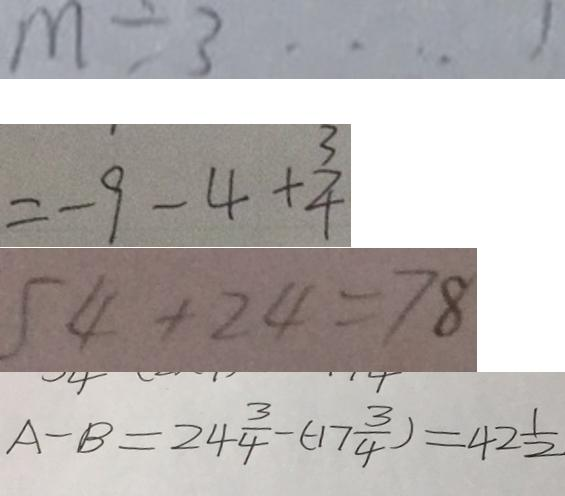Convert formula to latex. <formula><loc_0><loc_0><loc_500><loc_500>m \div 3 \cdots 1 
 = - 9 - 4 + \frac { 3 } { 4 } 
 5 4 + 2 4 = 7 8 
 A - B = 2 4 \frac { 3 } { 4 } - ( - 1 7 \frac { 3 } { 4 } ) = 4 2 \frac { 1 } { 2 }</formula> 